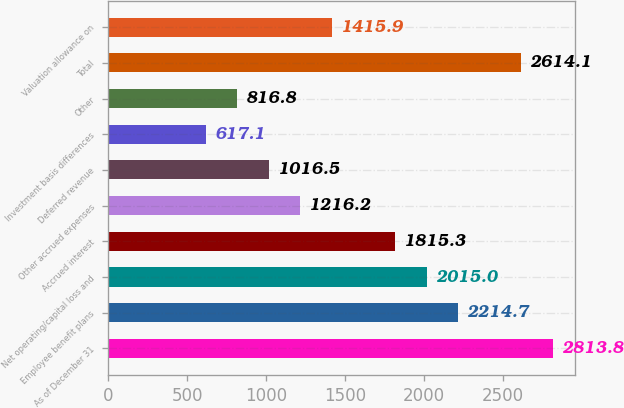Convert chart to OTSL. <chart><loc_0><loc_0><loc_500><loc_500><bar_chart><fcel>As of December 31<fcel>Employee benefit plans<fcel>Net operating/capital loss and<fcel>Accrued interest<fcel>Other accrued expenses<fcel>Deferred revenue<fcel>Investment basis differences<fcel>Other<fcel>Total<fcel>Valuation allowance on<nl><fcel>2813.8<fcel>2214.7<fcel>2015<fcel>1815.3<fcel>1216.2<fcel>1016.5<fcel>617.1<fcel>816.8<fcel>2614.1<fcel>1415.9<nl></chart> 